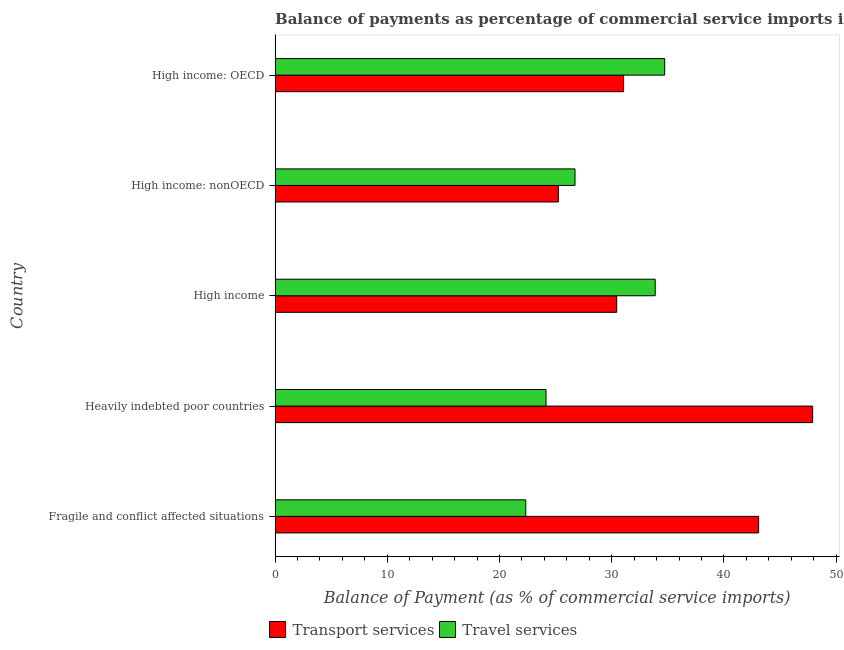How many groups of bars are there?
Provide a short and direct response. 5. How many bars are there on the 3rd tick from the bottom?
Offer a very short reply. 2. What is the balance of payments of travel services in High income: OECD?
Give a very brief answer. 34.72. Across all countries, what is the maximum balance of payments of travel services?
Your response must be concise. 34.72. Across all countries, what is the minimum balance of payments of travel services?
Provide a succinct answer. 22.34. In which country was the balance of payments of travel services maximum?
Your response must be concise. High income: OECD. In which country was the balance of payments of transport services minimum?
Your answer should be very brief. High income: nonOECD. What is the total balance of payments of transport services in the graph?
Ensure brevity in your answer.  177.75. What is the difference between the balance of payments of transport services in Fragile and conflict affected situations and that in High income: nonOECD?
Provide a succinct answer. 17.85. What is the difference between the balance of payments of transport services in High income and the balance of payments of travel services in Fragile and conflict affected situations?
Your answer should be compact. 8.1. What is the average balance of payments of travel services per country?
Provide a short and direct response. 28.36. What is the difference between the balance of payments of travel services and balance of payments of transport services in Fragile and conflict affected situations?
Your response must be concise. -20.75. In how many countries, is the balance of payments of travel services greater than 38 %?
Ensure brevity in your answer.  0. What is the ratio of the balance of payments of travel services in Fragile and conflict affected situations to that in Heavily indebted poor countries?
Offer a terse response. 0.93. Is the balance of payments of travel services in Heavily indebted poor countries less than that in High income: OECD?
Make the answer very short. Yes. What is the difference between the highest and the second highest balance of payments of transport services?
Provide a succinct answer. 4.81. What is the difference between the highest and the lowest balance of payments of travel services?
Your answer should be compact. 12.38. Is the sum of the balance of payments of travel services in Fragile and conflict affected situations and High income greater than the maximum balance of payments of transport services across all countries?
Provide a short and direct response. Yes. What does the 1st bar from the top in High income: nonOECD represents?
Give a very brief answer. Travel services. What does the 2nd bar from the bottom in High income represents?
Keep it short and to the point. Travel services. Are the values on the major ticks of X-axis written in scientific E-notation?
Your answer should be very brief. No. Does the graph contain any zero values?
Provide a short and direct response. No. Where does the legend appear in the graph?
Offer a terse response. Bottom center. What is the title of the graph?
Your answer should be compact. Balance of payments as percentage of commercial service imports in 2006. What is the label or title of the X-axis?
Your answer should be very brief. Balance of Payment (as % of commercial service imports). What is the Balance of Payment (as % of commercial service imports) in Transport services in Fragile and conflict affected situations?
Ensure brevity in your answer.  43.09. What is the Balance of Payment (as % of commercial service imports) of Travel services in Fragile and conflict affected situations?
Give a very brief answer. 22.34. What is the Balance of Payment (as % of commercial service imports) in Transport services in Heavily indebted poor countries?
Give a very brief answer. 47.9. What is the Balance of Payment (as % of commercial service imports) of Travel services in Heavily indebted poor countries?
Your answer should be compact. 24.15. What is the Balance of Payment (as % of commercial service imports) in Transport services in High income?
Provide a succinct answer. 30.44. What is the Balance of Payment (as % of commercial service imports) of Travel services in High income?
Ensure brevity in your answer.  33.88. What is the Balance of Payment (as % of commercial service imports) in Transport services in High income: nonOECD?
Give a very brief answer. 25.25. What is the Balance of Payment (as % of commercial service imports) of Travel services in High income: nonOECD?
Offer a very short reply. 26.73. What is the Balance of Payment (as % of commercial service imports) of Transport services in High income: OECD?
Make the answer very short. 31.06. What is the Balance of Payment (as % of commercial service imports) in Travel services in High income: OECD?
Keep it short and to the point. 34.72. Across all countries, what is the maximum Balance of Payment (as % of commercial service imports) in Transport services?
Your answer should be very brief. 47.9. Across all countries, what is the maximum Balance of Payment (as % of commercial service imports) in Travel services?
Offer a very short reply. 34.72. Across all countries, what is the minimum Balance of Payment (as % of commercial service imports) in Transport services?
Ensure brevity in your answer.  25.25. Across all countries, what is the minimum Balance of Payment (as % of commercial service imports) in Travel services?
Provide a succinct answer. 22.34. What is the total Balance of Payment (as % of commercial service imports) in Transport services in the graph?
Offer a very short reply. 177.75. What is the total Balance of Payment (as % of commercial service imports) in Travel services in the graph?
Ensure brevity in your answer.  141.81. What is the difference between the Balance of Payment (as % of commercial service imports) of Transport services in Fragile and conflict affected situations and that in Heavily indebted poor countries?
Keep it short and to the point. -4.81. What is the difference between the Balance of Payment (as % of commercial service imports) in Travel services in Fragile and conflict affected situations and that in Heavily indebted poor countries?
Keep it short and to the point. -1.8. What is the difference between the Balance of Payment (as % of commercial service imports) in Transport services in Fragile and conflict affected situations and that in High income?
Your answer should be compact. 12.65. What is the difference between the Balance of Payment (as % of commercial service imports) of Travel services in Fragile and conflict affected situations and that in High income?
Offer a very short reply. -11.53. What is the difference between the Balance of Payment (as % of commercial service imports) of Transport services in Fragile and conflict affected situations and that in High income: nonOECD?
Give a very brief answer. 17.85. What is the difference between the Balance of Payment (as % of commercial service imports) of Travel services in Fragile and conflict affected situations and that in High income: nonOECD?
Keep it short and to the point. -4.39. What is the difference between the Balance of Payment (as % of commercial service imports) of Transport services in Fragile and conflict affected situations and that in High income: OECD?
Your answer should be very brief. 12.04. What is the difference between the Balance of Payment (as % of commercial service imports) of Travel services in Fragile and conflict affected situations and that in High income: OECD?
Offer a very short reply. -12.38. What is the difference between the Balance of Payment (as % of commercial service imports) of Transport services in Heavily indebted poor countries and that in High income?
Your response must be concise. 17.46. What is the difference between the Balance of Payment (as % of commercial service imports) of Travel services in Heavily indebted poor countries and that in High income?
Provide a short and direct response. -9.73. What is the difference between the Balance of Payment (as % of commercial service imports) in Transport services in Heavily indebted poor countries and that in High income: nonOECD?
Your answer should be very brief. 22.66. What is the difference between the Balance of Payment (as % of commercial service imports) in Travel services in Heavily indebted poor countries and that in High income: nonOECD?
Give a very brief answer. -2.58. What is the difference between the Balance of Payment (as % of commercial service imports) in Transport services in Heavily indebted poor countries and that in High income: OECD?
Ensure brevity in your answer.  16.85. What is the difference between the Balance of Payment (as % of commercial service imports) of Travel services in Heavily indebted poor countries and that in High income: OECD?
Offer a terse response. -10.57. What is the difference between the Balance of Payment (as % of commercial service imports) of Transport services in High income and that in High income: nonOECD?
Keep it short and to the point. 5.2. What is the difference between the Balance of Payment (as % of commercial service imports) of Travel services in High income and that in High income: nonOECD?
Ensure brevity in your answer.  7.15. What is the difference between the Balance of Payment (as % of commercial service imports) of Transport services in High income and that in High income: OECD?
Offer a very short reply. -0.61. What is the difference between the Balance of Payment (as % of commercial service imports) in Travel services in High income and that in High income: OECD?
Your answer should be very brief. -0.84. What is the difference between the Balance of Payment (as % of commercial service imports) of Transport services in High income: nonOECD and that in High income: OECD?
Your answer should be very brief. -5.81. What is the difference between the Balance of Payment (as % of commercial service imports) in Travel services in High income: nonOECD and that in High income: OECD?
Give a very brief answer. -7.99. What is the difference between the Balance of Payment (as % of commercial service imports) of Transport services in Fragile and conflict affected situations and the Balance of Payment (as % of commercial service imports) of Travel services in Heavily indebted poor countries?
Offer a terse response. 18.95. What is the difference between the Balance of Payment (as % of commercial service imports) of Transport services in Fragile and conflict affected situations and the Balance of Payment (as % of commercial service imports) of Travel services in High income?
Keep it short and to the point. 9.22. What is the difference between the Balance of Payment (as % of commercial service imports) of Transport services in Fragile and conflict affected situations and the Balance of Payment (as % of commercial service imports) of Travel services in High income: nonOECD?
Your answer should be very brief. 16.36. What is the difference between the Balance of Payment (as % of commercial service imports) in Transport services in Fragile and conflict affected situations and the Balance of Payment (as % of commercial service imports) in Travel services in High income: OECD?
Your response must be concise. 8.37. What is the difference between the Balance of Payment (as % of commercial service imports) of Transport services in Heavily indebted poor countries and the Balance of Payment (as % of commercial service imports) of Travel services in High income?
Provide a succinct answer. 14.03. What is the difference between the Balance of Payment (as % of commercial service imports) in Transport services in Heavily indebted poor countries and the Balance of Payment (as % of commercial service imports) in Travel services in High income: nonOECD?
Your answer should be compact. 21.17. What is the difference between the Balance of Payment (as % of commercial service imports) in Transport services in Heavily indebted poor countries and the Balance of Payment (as % of commercial service imports) in Travel services in High income: OECD?
Make the answer very short. 13.18. What is the difference between the Balance of Payment (as % of commercial service imports) of Transport services in High income and the Balance of Payment (as % of commercial service imports) of Travel services in High income: nonOECD?
Keep it short and to the point. 3.71. What is the difference between the Balance of Payment (as % of commercial service imports) in Transport services in High income and the Balance of Payment (as % of commercial service imports) in Travel services in High income: OECD?
Provide a succinct answer. -4.28. What is the difference between the Balance of Payment (as % of commercial service imports) of Transport services in High income: nonOECD and the Balance of Payment (as % of commercial service imports) of Travel services in High income: OECD?
Give a very brief answer. -9.47. What is the average Balance of Payment (as % of commercial service imports) in Transport services per country?
Provide a succinct answer. 35.55. What is the average Balance of Payment (as % of commercial service imports) in Travel services per country?
Give a very brief answer. 28.36. What is the difference between the Balance of Payment (as % of commercial service imports) of Transport services and Balance of Payment (as % of commercial service imports) of Travel services in Fragile and conflict affected situations?
Offer a terse response. 20.75. What is the difference between the Balance of Payment (as % of commercial service imports) in Transport services and Balance of Payment (as % of commercial service imports) in Travel services in Heavily indebted poor countries?
Keep it short and to the point. 23.76. What is the difference between the Balance of Payment (as % of commercial service imports) in Transport services and Balance of Payment (as % of commercial service imports) in Travel services in High income?
Keep it short and to the point. -3.43. What is the difference between the Balance of Payment (as % of commercial service imports) in Transport services and Balance of Payment (as % of commercial service imports) in Travel services in High income: nonOECD?
Make the answer very short. -1.48. What is the difference between the Balance of Payment (as % of commercial service imports) in Transport services and Balance of Payment (as % of commercial service imports) in Travel services in High income: OECD?
Give a very brief answer. -3.66. What is the ratio of the Balance of Payment (as % of commercial service imports) in Transport services in Fragile and conflict affected situations to that in Heavily indebted poor countries?
Give a very brief answer. 0.9. What is the ratio of the Balance of Payment (as % of commercial service imports) of Travel services in Fragile and conflict affected situations to that in Heavily indebted poor countries?
Ensure brevity in your answer.  0.93. What is the ratio of the Balance of Payment (as % of commercial service imports) of Transport services in Fragile and conflict affected situations to that in High income?
Give a very brief answer. 1.42. What is the ratio of the Balance of Payment (as % of commercial service imports) of Travel services in Fragile and conflict affected situations to that in High income?
Offer a very short reply. 0.66. What is the ratio of the Balance of Payment (as % of commercial service imports) in Transport services in Fragile and conflict affected situations to that in High income: nonOECD?
Provide a short and direct response. 1.71. What is the ratio of the Balance of Payment (as % of commercial service imports) in Travel services in Fragile and conflict affected situations to that in High income: nonOECD?
Give a very brief answer. 0.84. What is the ratio of the Balance of Payment (as % of commercial service imports) of Transport services in Fragile and conflict affected situations to that in High income: OECD?
Provide a short and direct response. 1.39. What is the ratio of the Balance of Payment (as % of commercial service imports) in Travel services in Fragile and conflict affected situations to that in High income: OECD?
Keep it short and to the point. 0.64. What is the ratio of the Balance of Payment (as % of commercial service imports) in Transport services in Heavily indebted poor countries to that in High income?
Ensure brevity in your answer.  1.57. What is the ratio of the Balance of Payment (as % of commercial service imports) of Travel services in Heavily indebted poor countries to that in High income?
Offer a terse response. 0.71. What is the ratio of the Balance of Payment (as % of commercial service imports) in Transport services in Heavily indebted poor countries to that in High income: nonOECD?
Give a very brief answer. 1.9. What is the ratio of the Balance of Payment (as % of commercial service imports) of Travel services in Heavily indebted poor countries to that in High income: nonOECD?
Offer a terse response. 0.9. What is the ratio of the Balance of Payment (as % of commercial service imports) in Transport services in Heavily indebted poor countries to that in High income: OECD?
Give a very brief answer. 1.54. What is the ratio of the Balance of Payment (as % of commercial service imports) in Travel services in Heavily indebted poor countries to that in High income: OECD?
Your answer should be very brief. 0.7. What is the ratio of the Balance of Payment (as % of commercial service imports) of Transport services in High income to that in High income: nonOECD?
Your response must be concise. 1.21. What is the ratio of the Balance of Payment (as % of commercial service imports) of Travel services in High income to that in High income: nonOECD?
Provide a short and direct response. 1.27. What is the ratio of the Balance of Payment (as % of commercial service imports) of Transport services in High income to that in High income: OECD?
Make the answer very short. 0.98. What is the ratio of the Balance of Payment (as % of commercial service imports) in Travel services in High income to that in High income: OECD?
Offer a very short reply. 0.98. What is the ratio of the Balance of Payment (as % of commercial service imports) of Transport services in High income: nonOECD to that in High income: OECD?
Your response must be concise. 0.81. What is the ratio of the Balance of Payment (as % of commercial service imports) of Travel services in High income: nonOECD to that in High income: OECD?
Offer a very short reply. 0.77. What is the difference between the highest and the second highest Balance of Payment (as % of commercial service imports) in Transport services?
Offer a very short reply. 4.81. What is the difference between the highest and the second highest Balance of Payment (as % of commercial service imports) of Travel services?
Provide a succinct answer. 0.84. What is the difference between the highest and the lowest Balance of Payment (as % of commercial service imports) in Transport services?
Your answer should be very brief. 22.66. What is the difference between the highest and the lowest Balance of Payment (as % of commercial service imports) in Travel services?
Ensure brevity in your answer.  12.38. 